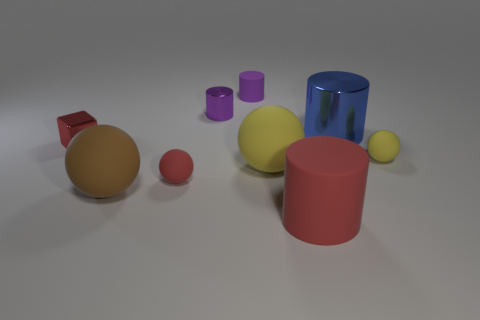How does the lighting in the scene affect the appearance of the objects? The scene is lit from above, casting subtle shadows beneath the objects. This overhead lighting highlights the textures and materials, such as the shine on the metallic blue cylinder and the softer appearance of the matte objects. 